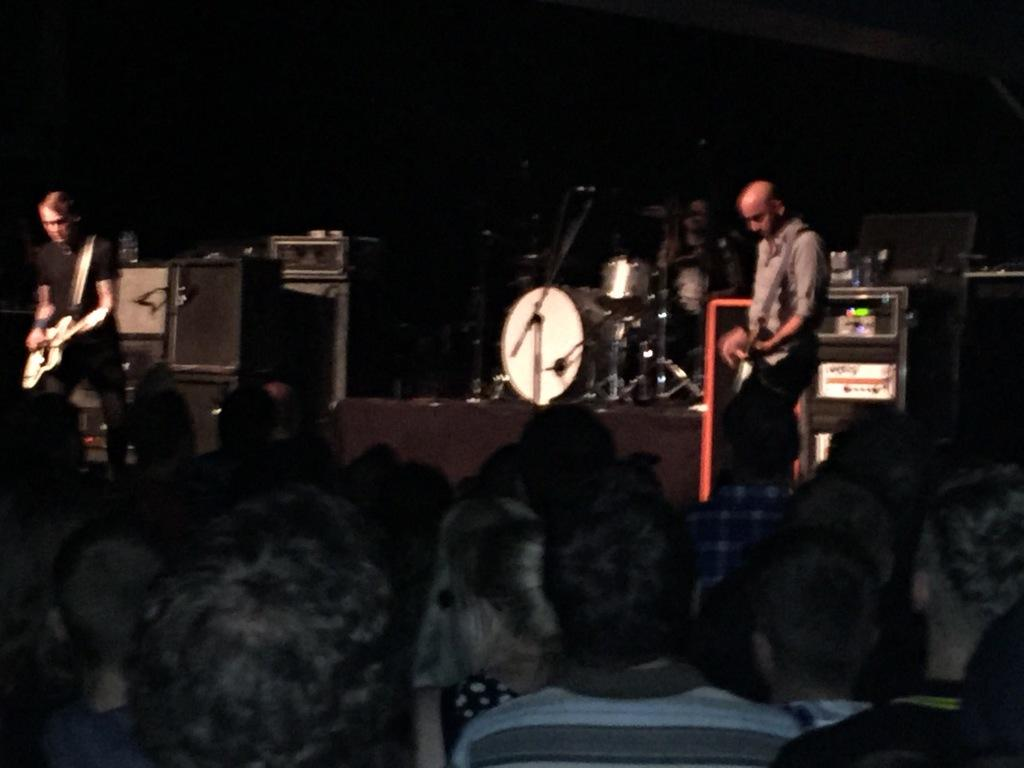What are the people in the image doing? The people in the image are sitting and standing, and some of them are singing. Are there any objects related to music in the image? Yes, there are music instruments in the image. Can you see a crown on the head of the boy in the image? There is no boy or crown present in the image. What type of boot is being used by the people in the image? There are no boots visible in the image; the people are not wearing any footwear. 